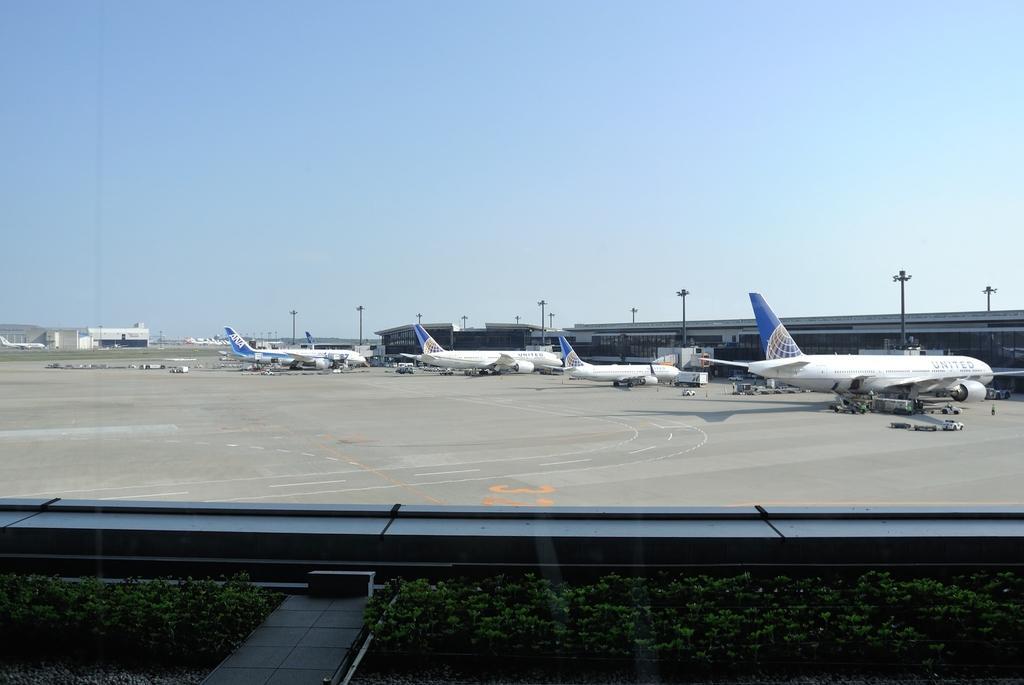Could you give a brief overview of what you see in this image? In this picture we can see a path, plants, glass, from the glass we can see airplanes, vehicles on the ground, here we can see buildings, electric poles and we can see sky in the background. 